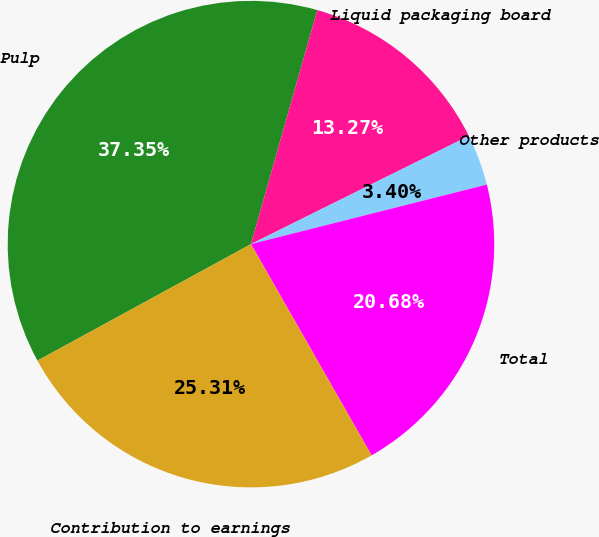Convert chart to OTSL. <chart><loc_0><loc_0><loc_500><loc_500><pie_chart><fcel>Pulp<fcel>Liquid packaging board<fcel>Other products<fcel>Total<fcel>Contribution to earnings<nl><fcel>37.35%<fcel>13.27%<fcel>3.4%<fcel>20.68%<fcel>25.31%<nl></chart> 